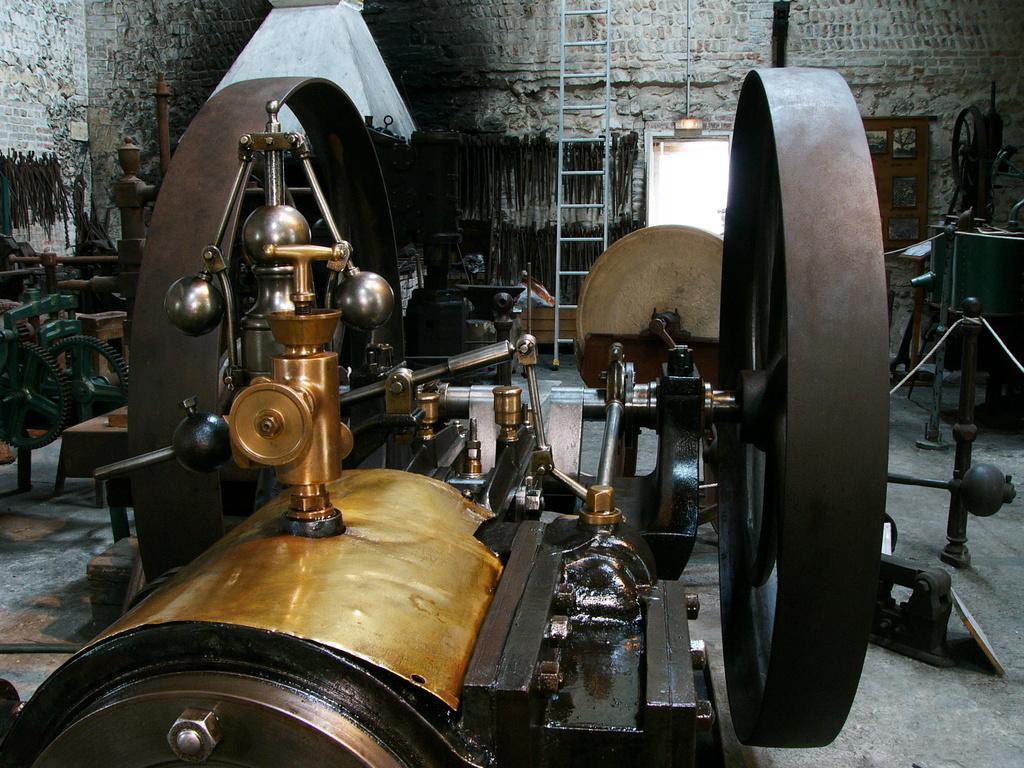In one or two sentences, can you explain what this image depicts? In this image there are few machines kept on the floor. A ladder is kept near the wall having a door to it. 